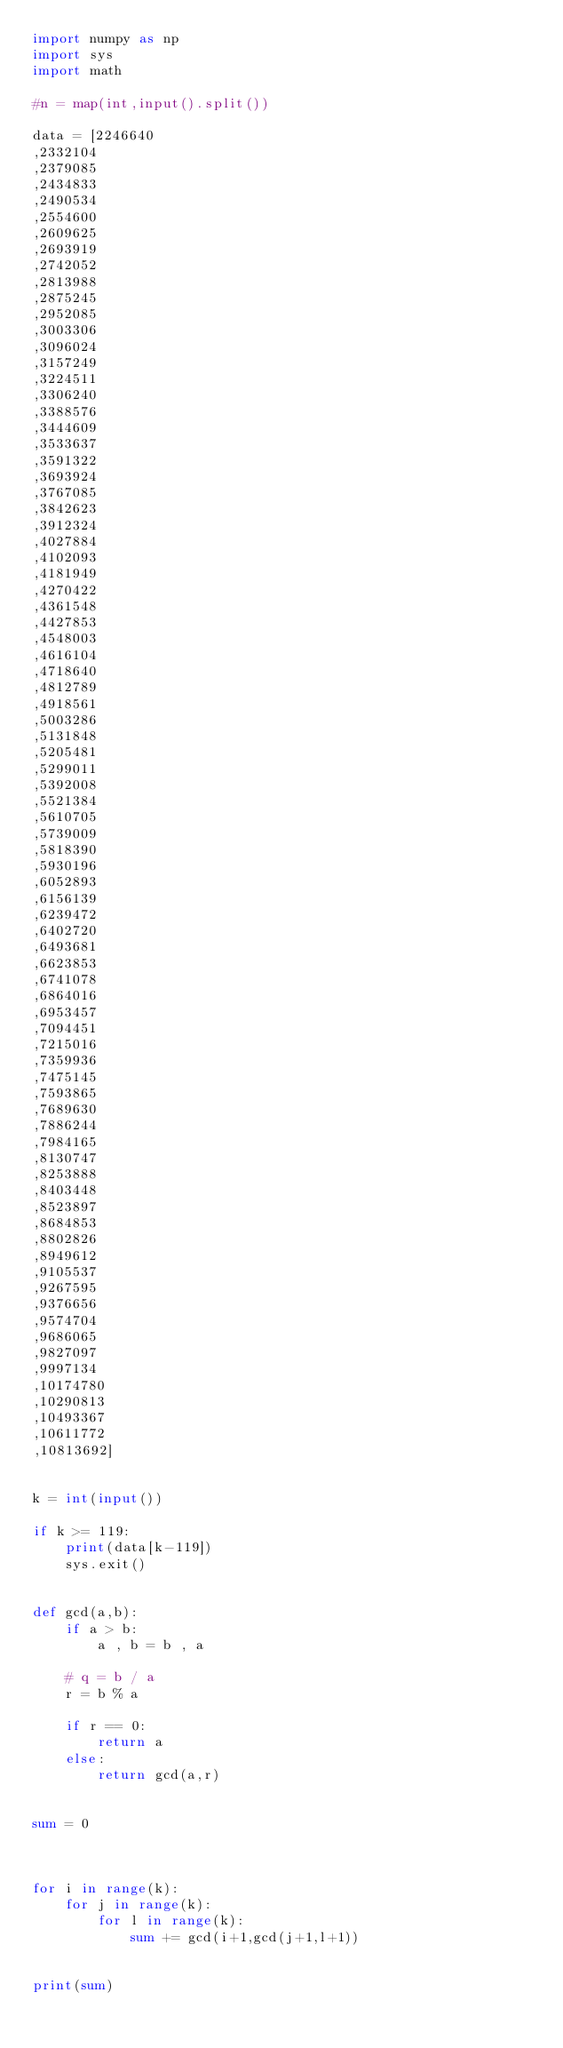Convert code to text. <code><loc_0><loc_0><loc_500><loc_500><_Python_>import numpy as np
import sys
import math

#n = map(int,input().split())

data = [2246640
,2332104
,2379085
,2434833
,2490534
,2554600
,2609625
,2693919
,2742052
,2813988
,2875245
,2952085
,3003306
,3096024
,3157249
,3224511
,3306240
,3388576
,3444609
,3533637
,3591322
,3693924
,3767085
,3842623
,3912324
,4027884
,4102093
,4181949
,4270422
,4361548
,4427853
,4548003
,4616104
,4718640
,4812789
,4918561
,5003286
,5131848
,5205481
,5299011
,5392008
,5521384
,5610705
,5739009
,5818390
,5930196
,6052893
,6156139
,6239472
,6402720
,6493681
,6623853
,6741078
,6864016
,6953457
,7094451
,7215016
,7359936
,7475145
,7593865
,7689630
,7886244
,7984165
,8130747
,8253888
,8403448
,8523897
,8684853
,8802826
,8949612
,9105537
,9267595
,9376656
,9574704
,9686065
,9827097
,9997134
,10174780
,10290813
,10493367
,10611772
,10813692]


k = int(input())

if k >= 119:
    print(data[k-119])
    sys.exit()


def gcd(a,b):
    if a > b:
        a , b = b , a

    # q = b / a
    r = b % a

    if r == 0:
        return a
    else:
        return gcd(a,r)
    

sum = 0



for i in range(k):
    for j in range(k):
        for l in range(k):
            sum += gcd(i+1,gcd(j+1,l+1))


print(sum)</code> 